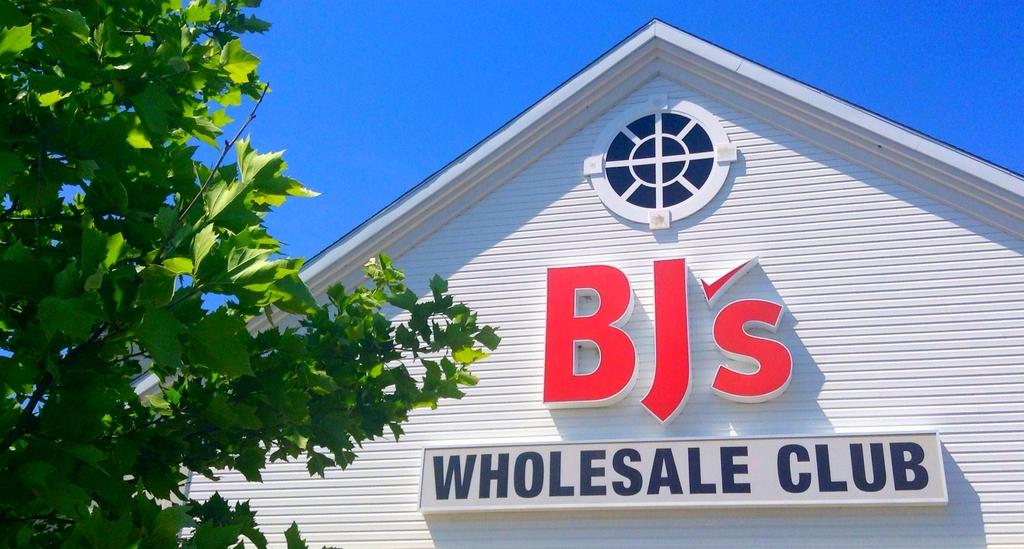What's the name of this wholesale club?
Give a very brief answer. Bj's. What do they sell at bj"s ?
Your answer should be very brief. Wholesale. 